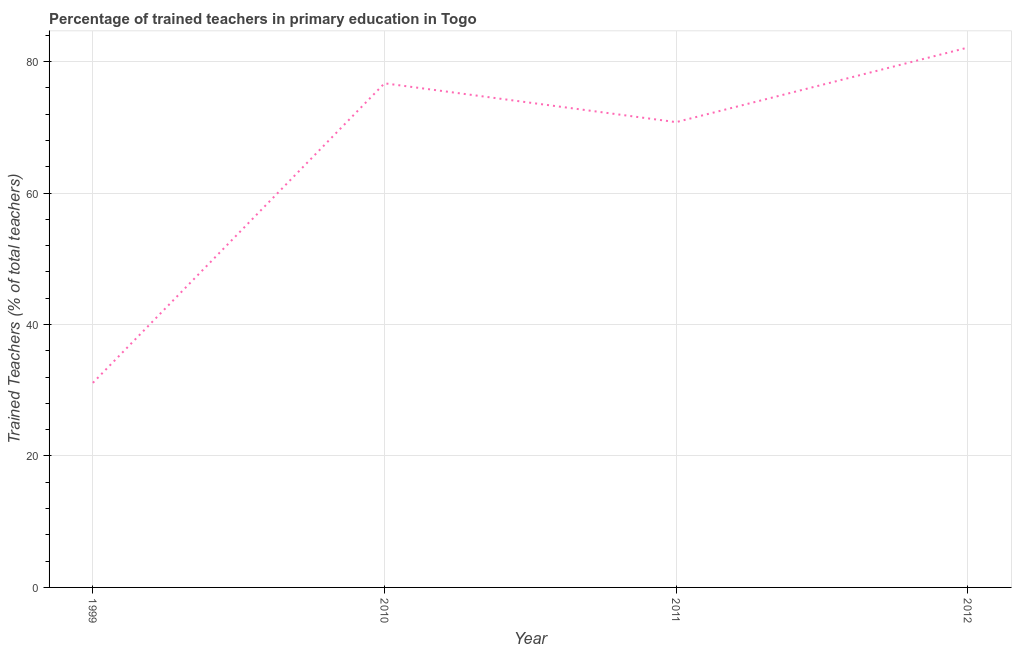What is the percentage of trained teachers in 2011?
Offer a terse response. 70.8. Across all years, what is the maximum percentage of trained teachers?
Keep it short and to the point. 82.14. Across all years, what is the minimum percentage of trained teachers?
Your answer should be compact. 31.12. In which year was the percentage of trained teachers maximum?
Give a very brief answer. 2012. What is the sum of the percentage of trained teachers?
Your response must be concise. 260.76. What is the difference between the percentage of trained teachers in 2010 and 2012?
Keep it short and to the point. -5.44. What is the average percentage of trained teachers per year?
Provide a short and direct response. 65.19. What is the median percentage of trained teachers?
Offer a terse response. 73.75. In how many years, is the percentage of trained teachers greater than 72 %?
Offer a very short reply. 2. Do a majority of the years between 1999 and 2012 (inclusive) have percentage of trained teachers greater than 76 %?
Provide a short and direct response. No. What is the ratio of the percentage of trained teachers in 1999 to that in 2010?
Offer a very short reply. 0.41. What is the difference between the highest and the second highest percentage of trained teachers?
Offer a terse response. 5.44. Is the sum of the percentage of trained teachers in 2011 and 2012 greater than the maximum percentage of trained teachers across all years?
Your response must be concise. Yes. What is the difference between the highest and the lowest percentage of trained teachers?
Make the answer very short. 51.01. In how many years, is the percentage of trained teachers greater than the average percentage of trained teachers taken over all years?
Give a very brief answer. 3. Does the percentage of trained teachers monotonically increase over the years?
Provide a succinct answer. No. What is the difference between two consecutive major ticks on the Y-axis?
Offer a very short reply. 20. Are the values on the major ticks of Y-axis written in scientific E-notation?
Give a very brief answer. No. Does the graph contain grids?
Your answer should be compact. Yes. What is the title of the graph?
Provide a succinct answer. Percentage of trained teachers in primary education in Togo. What is the label or title of the Y-axis?
Give a very brief answer. Trained Teachers (% of total teachers). What is the Trained Teachers (% of total teachers) in 1999?
Ensure brevity in your answer.  31.12. What is the Trained Teachers (% of total teachers) in 2010?
Ensure brevity in your answer.  76.7. What is the Trained Teachers (% of total teachers) in 2011?
Provide a short and direct response. 70.8. What is the Trained Teachers (% of total teachers) of 2012?
Your answer should be very brief. 82.14. What is the difference between the Trained Teachers (% of total teachers) in 1999 and 2010?
Ensure brevity in your answer.  -45.58. What is the difference between the Trained Teachers (% of total teachers) in 1999 and 2011?
Your answer should be compact. -39.67. What is the difference between the Trained Teachers (% of total teachers) in 1999 and 2012?
Provide a succinct answer. -51.01. What is the difference between the Trained Teachers (% of total teachers) in 2010 and 2011?
Offer a terse response. 5.91. What is the difference between the Trained Teachers (% of total teachers) in 2010 and 2012?
Your answer should be compact. -5.44. What is the difference between the Trained Teachers (% of total teachers) in 2011 and 2012?
Make the answer very short. -11.34. What is the ratio of the Trained Teachers (% of total teachers) in 1999 to that in 2010?
Keep it short and to the point. 0.41. What is the ratio of the Trained Teachers (% of total teachers) in 1999 to that in 2011?
Offer a very short reply. 0.44. What is the ratio of the Trained Teachers (% of total teachers) in 1999 to that in 2012?
Keep it short and to the point. 0.38. What is the ratio of the Trained Teachers (% of total teachers) in 2010 to that in 2011?
Keep it short and to the point. 1.08. What is the ratio of the Trained Teachers (% of total teachers) in 2010 to that in 2012?
Provide a short and direct response. 0.93. What is the ratio of the Trained Teachers (% of total teachers) in 2011 to that in 2012?
Offer a terse response. 0.86. 